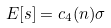<formula> <loc_0><loc_0><loc_500><loc_500>E [ s ] = c _ { 4 } ( n ) \sigma</formula> 